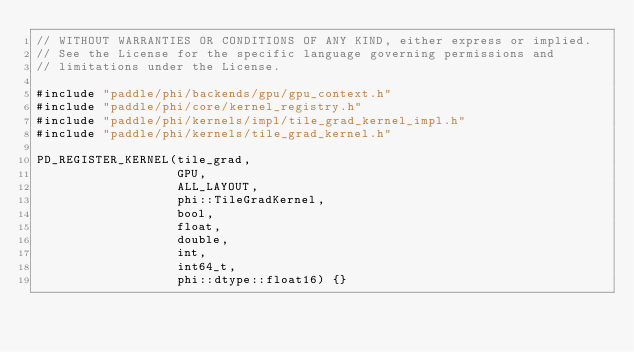Convert code to text. <code><loc_0><loc_0><loc_500><loc_500><_Cuda_>// WITHOUT WARRANTIES OR CONDITIONS OF ANY KIND, either express or implied.
// See the License for the specific language governing permissions and
// limitations under the License.

#include "paddle/phi/backends/gpu/gpu_context.h"
#include "paddle/phi/core/kernel_registry.h"
#include "paddle/phi/kernels/impl/tile_grad_kernel_impl.h"
#include "paddle/phi/kernels/tile_grad_kernel.h"

PD_REGISTER_KERNEL(tile_grad,
                   GPU,
                   ALL_LAYOUT,
                   phi::TileGradKernel,
                   bool,
                   float,
                   double,
                   int,
                   int64_t,
                   phi::dtype::float16) {}
</code> 